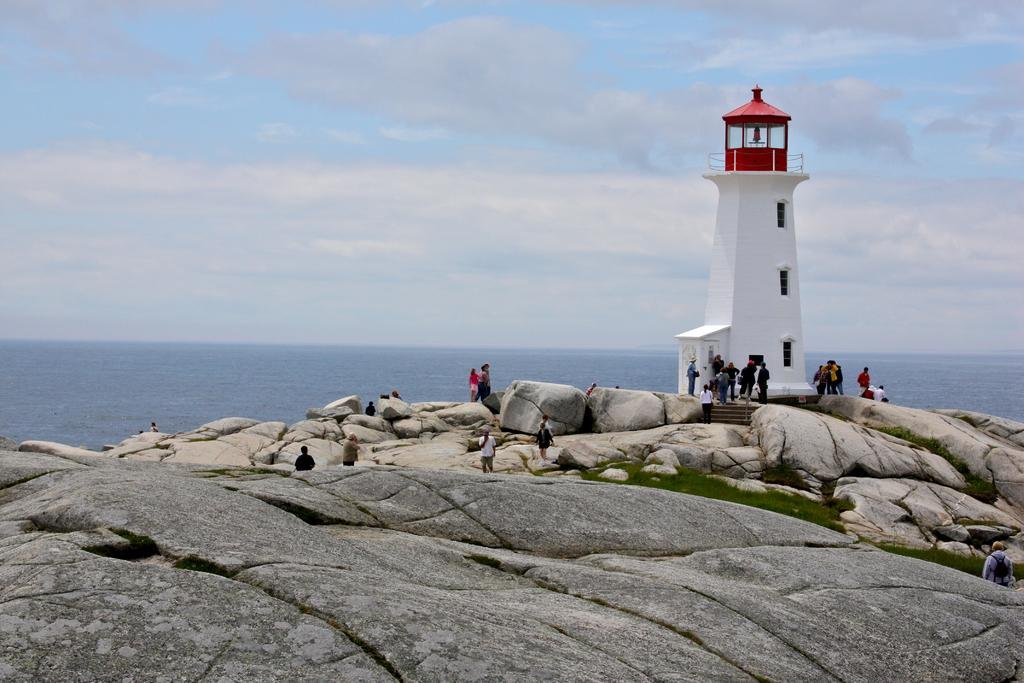What is the main feature of the image? There is an ocean in the image. What structure is located in front of the ocean? There is a tower in front of the ocean. Can you describe the people in the image? There are people on the rocks in the image. What type of bucket can be seen floating in the ocean in the image? There is no bucket present in the image. 